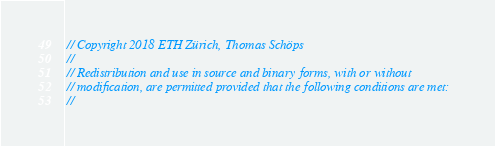<code> <loc_0><loc_0><loc_500><loc_500><_Cuda_>// Copyright 2018 ETH Zürich, Thomas Schöps
//
// Redistribution and use in source and binary forms, with or without
// modification, are permitted provided that the following conditions are met:
//</code> 